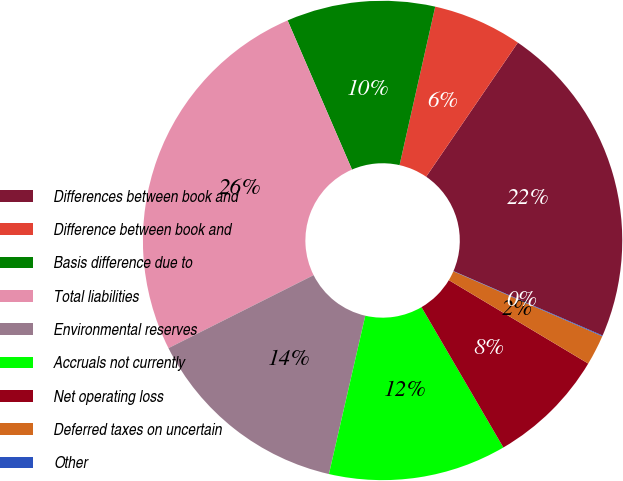Convert chart to OTSL. <chart><loc_0><loc_0><loc_500><loc_500><pie_chart><fcel>Differences between book and<fcel>Difference between book and<fcel>Basis difference due to<fcel>Total liabilities<fcel>Environmental reserves<fcel>Accruals not currently<fcel>Net operating loss<fcel>Deferred taxes on uncertain<fcel>Other<nl><fcel>21.95%<fcel>6.02%<fcel>10.01%<fcel>25.93%<fcel>13.99%<fcel>12.0%<fcel>8.01%<fcel>2.04%<fcel>0.05%<nl></chart> 